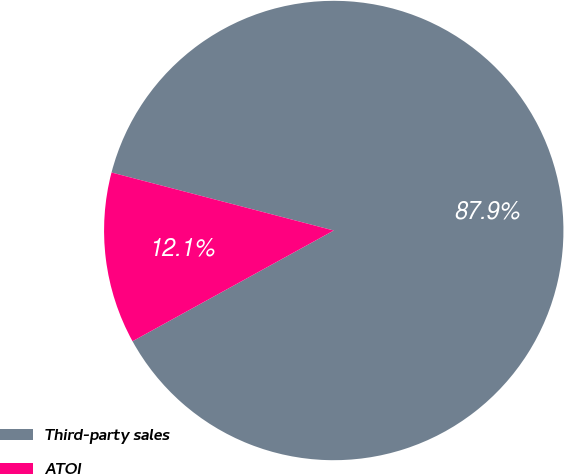<chart> <loc_0><loc_0><loc_500><loc_500><pie_chart><fcel>Third-party sales<fcel>ATOI<nl><fcel>87.93%<fcel>12.07%<nl></chart> 